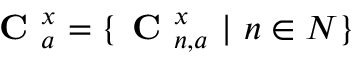<formula> <loc_0><loc_0><loc_500><loc_500>C _ { a } ^ { x } = \{ C _ { n , a } ^ { x } \ | \ n \in N \}</formula> 